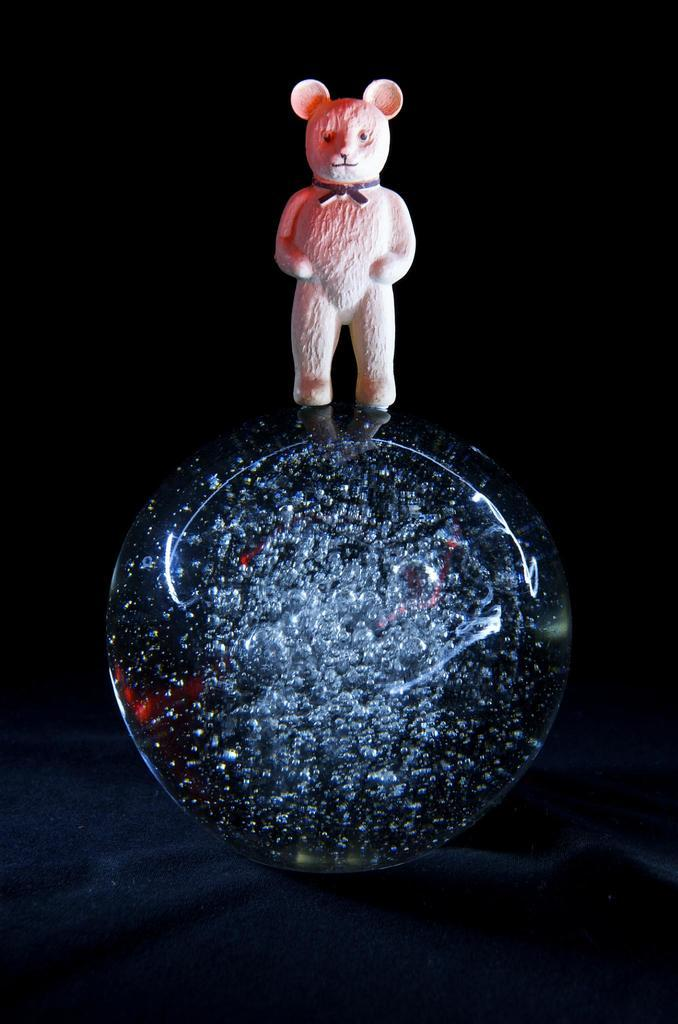What is the main subject of the image? The main subject of the image is a doll. What is the doll placed on? The doll is on a crystal. What type of apparel is the doll wearing in the image? The provided facts do not mention any apparel on the doll, so we cannot determine what type of clothing the doll is wearing. 